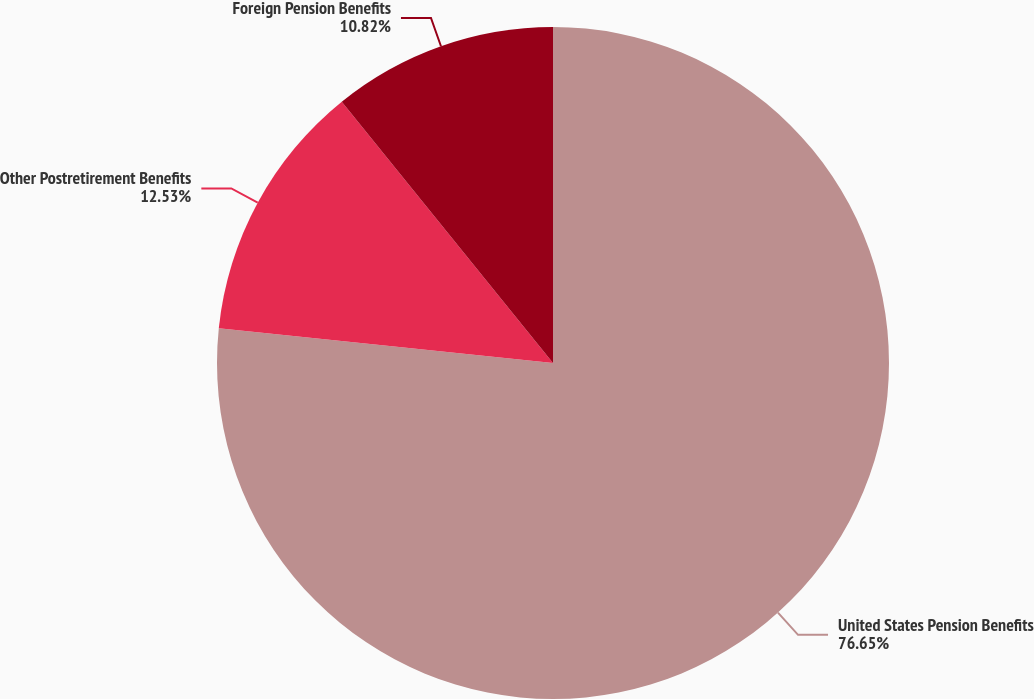Convert chart to OTSL. <chart><loc_0><loc_0><loc_500><loc_500><pie_chart><fcel>United States Pension Benefits<fcel>Other Postretirement Benefits<fcel>Foreign Pension Benefits<nl><fcel>76.65%<fcel>12.53%<fcel>10.82%<nl></chart> 